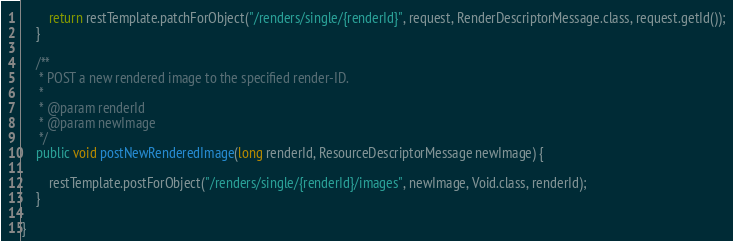<code> <loc_0><loc_0><loc_500><loc_500><_Java_>		return restTemplate.patchForObject("/renders/single/{renderId}", request, RenderDescriptorMessage.class, request.getId());
	}

	/**
	 * POST a new rendered image to the specified render-ID.
	 * 
	 * @param renderId
	 * @param newImage
	 */
	public void postNewRenderedImage(long renderId, ResourceDescriptorMessage newImage) {

		restTemplate.postForObject("/renders/single/{renderId}/images", newImage, Void.class, renderId);
	}

}
</code> 